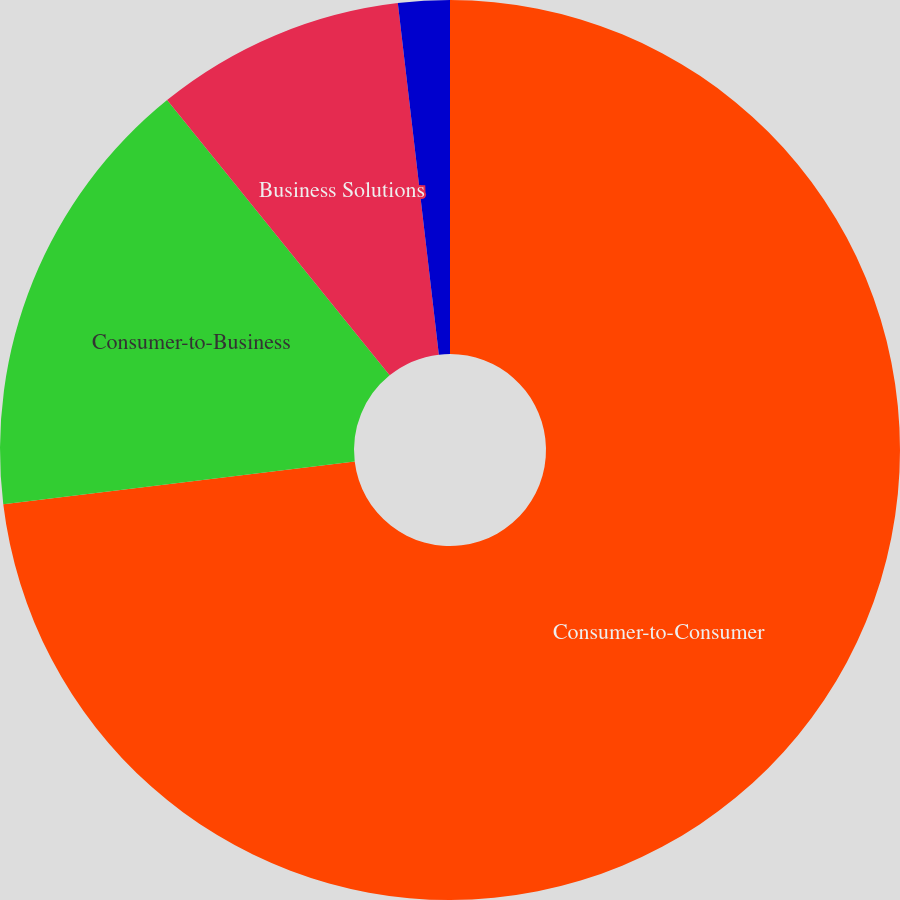Convert chart. <chart><loc_0><loc_0><loc_500><loc_500><pie_chart><fcel>Consumer-to-Consumer<fcel>Consumer-to-Business<fcel>Business Solutions<fcel>Other<nl><fcel>73.08%<fcel>16.1%<fcel>8.97%<fcel>1.85%<nl></chart> 